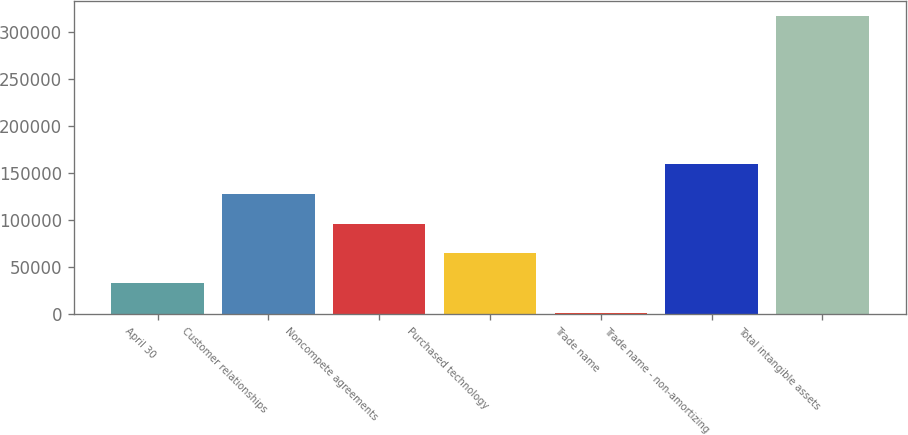<chart> <loc_0><loc_0><loc_500><loc_500><bar_chart><fcel>April 30<fcel>Customer relationships<fcel>Noncompete agreements<fcel>Purchased technology<fcel>Trade name<fcel>Trade name - non-amortizing<fcel>Total intangible assets<nl><fcel>32682.7<fcel>127656<fcel>95998.1<fcel>64340.4<fcel>1025<fcel>159314<fcel>317602<nl></chart> 